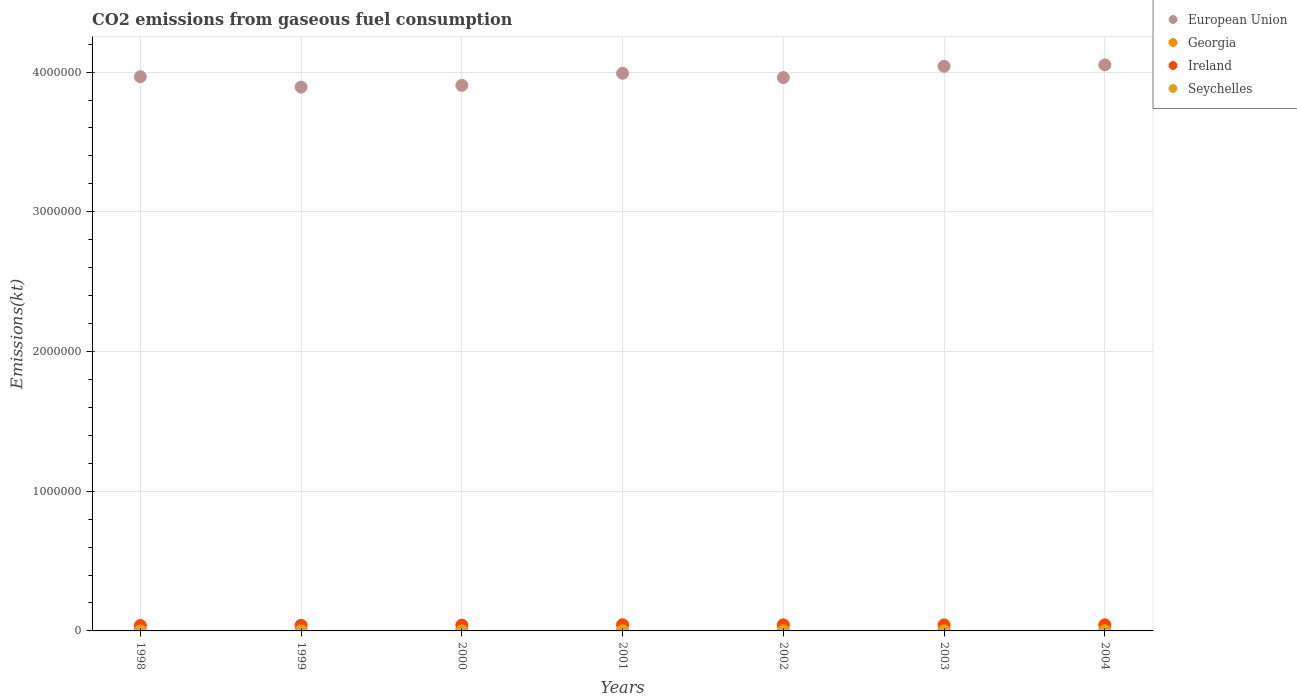How many different coloured dotlines are there?
Make the answer very short. 4. What is the amount of CO2 emitted in Georgia in 2004?
Your answer should be very brief. 4323.39. Across all years, what is the maximum amount of CO2 emitted in European Union?
Offer a terse response. 4.05e+06. Across all years, what is the minimum amount of CO2 emitted in Seychelles?
Keep it short and to the point. 432.71. In which year was the amount of CO2 emitted in Ireland maximum?
Provide a succinct answer. 2001. What is the total amount of CO2 emitted in European Union in the graph?
Offer a very short reply. 2.78e+07. What is the difference between the amount of CO2 emitted in Seychelles in 1998 and that in 2000?
Provide a succinct answer. -124.68. What is the difference between the amount of CO2 emitted in Ireland in 1999 and the amount of CO2 emitted in European Union in 2000?
Provide a short and direct response. -3.87e+06. What is the average amount of CO2 emitted in Georgia per year?
Provide a short and direct response. 4156.81. In the year 1998, what is the difference between the amount of CO2 emitted in Seychelles and amount of CO2 emitted in European Union?
Your answer should be compact. -3.97e+06. In how many years, is the amount of CO2 emitted in Seychelles greater than 1600000 kt?
Offer a very short reply. 0. What is the ratio of the amount of CO2 emitted in Seychelles in 2002 to that in 2004?
Your answer should be compact. 0.73. Is the amount of CO2 emitted in Seychelles in 1998 less than that in 2002?
Provide a short and direct response. Yes. Is the difference between the amount of CO2 emitted in Seychelles in 2000 and 2002 greater than the difference between the amount of CO2 emitted in European Union in 2000 and 2002?
Keep it short and to the point. Yes. What is the difference between the highest and the second highest amount of CO2 emitted in Georgia?
Offer a very short reply. 425.37. What is the difference between the highest and the lowest amount of CO2 emitted in European Union?
Keep it short and to the point. 1.59e+05. In how many years, is the amount of CO2 emitted in European Union greater than the average amount of CO2 emitted in European Union taken over all years?
Provide a succinct answer. 3. Is it the case that in every year, the sum of the amount of CO2 emitted in Seychelles and amount of CO2 emitted in Ireland  is greater than the sum of amount of CO2 emitted in European Union and amount of CO2 emitted in Georgia?
Give a very brief answer. No. Is it the case that in every year, the sum of the amount of CO2 emitted in Georgia and amount of CO2 emitted in Ireland  is greater than the amount of CO2 emitted in Seychelles?
Make the answer very short. Yes. Does the amount of CO2 emitted in European Union monotonically increase over the years?
Provide a short and direct response. No. Is the amount of CO2 emitted in European Union strictly greater than the amount of CO2 emitted in Seychelles over the years?
Make the answer very short. Yes. Is the amount of CO2 emitted in Seychelles strictly less than the amount of CO2 emitted in European Union over the years?
Offer a terse response. Yes. How many years are there in the graph?
Make the answer very short. 7. What is the difference between two consecutive major ticks on the Y-axis?
Ensure brevity in your answer.  1.00e+06. Are the values on the major ticks of Y-axis written in scientific E-notation?
Your response must be concise. No. Does the graph contain grids?
Ensure brevity in your answer.  Yes. How are the legend labels stacked?
Give a very brief answer. Vertical. What is the title of the graph?
Provide a succinct answer. CO2 emissions from gaseous fuel consumption. Does "Curacao" appear as one of the legend labels in the graph?
Offer a very short reply. No. What is the label or title of the X-axis?
Make the answer very short. Years. What is the label or title of the Y-axis?
Make the answer very short. Emissions(kt). What is the Emissions(kt) of European Union in 1998?
Provide a short and direct response. 3.97e+06. What is the Emissions(kt) of Georgia in 1998?
Ensure brevity in your answer.  4961.45. What is the Emissions(kt) of Ireland in 1998?
Give a very brief answer. 3.86e+04. What is the Emissions(kt) of Seychelles in 1998?
Provide a short and direct response. 432.71. What is the Emissions(kt) in European Union in 1999?
Your answer should be compact. 3.89e+06. What is the Emissions(kt) of Georgia in 1999?
Offer a very short reply. 4345.4. What is the Emissions(kt) in Ireland in 1999?
Give a very brief answer. 4.01e+04. What is the Emissions(kt) in Seychelles in 1999?
Give a very brief answer. 506.05. What is the Emissions(kt) in European Union in 2000?
Your answer should be compact. 3.91e+06. What is the Emissions(kt) in Georgia in 2000?
Provide a succinct answer. 4536.08. What is the Emissions(kt) in Ireland in 2000?
Offer a terse response. 4.12e+04. What is the Emissions(kt) of Seychelles in 2000?
Make the answer very short. 557.38. What is the Emissions(kt) in European Union in 2001?
Provide a succinct answer. 3.99e+06. What is the Emissions(kt) of Georgia in 2001?
Offer a terse response. 3769.68. What is the Emissions(kt) in Ireland in 2001?
Provide a succinct answer. 4.40e+04. What is the Emissions(kt) of Seychelles in 2001?
Offer a very short reply. 634.39. What is the Emissions(kt) of European Union in 2002?
Your answer should be compact. 3.96e+06. What is the Emissions(kt) in Georgia in 2002?
Offer a very short reply. 3388.31. What is the Emissions(kt) in Ireland in 2002?
Your answer should be compact. 4.36e+04. What is the Emissions(kt) in Seychelles in 2002?
Your answer should be very brief. 539.05. What is the Emissions(kt) of European Union in 2003?
Make the answer very short. 4.04e+06. What is the Emissions(kt) in Georgia in 2003?
Your response must be concise. 3773.34. What is the Emissions(kt) in Ireland in 2003?
Give a very brief answer. 4.32e+04. What is the Emissions(kt) of Seychelles in 2003?
Offer a very short reply. 550.05. What is the Emissions(kt) of European Union in 2004?
Your answer should be compact. 4.05e+06. What is the Emissions(kt) in Georgia in 2004?
Your response must be concise. 4323.39. What is the Emissions(kt) in Ireland in 2004?
Your answer should be compact. 4.38e+04. What is the Emissions(kt) of Seychelles in 2004?
Make the answer very short. 737.07. Across all years, what is the maximum Emissions(kt) in European Union?
Ensure brevity in your answer.  4.05e+06. Across all years, what is the maximum Emissions(kt) of Georgia?
Offer a very short reply. 4961.45. Across all years, what is the maximum Emissions(kt) of Ireland?
Give a very brief answer. 4.40e+04. Across all years, what is the maximum Emissions(kt) in Seychelles?
Offer a terse response. 737.07. Across all years, what is the minimum Emissions(kt) of European Union?
Give a very brief answer. 3.89e+06. Across all years, what is the minimum Emissions(kt) of Georgia?
Provide a short and direct response. 3388.31. Across all years, what is the minimum Emissions(kt) in Ireland?
Provide a succinct answer. 3.86e+04. Across all years, what is the minimum Emissions(kt) in Seychelles?
Your answer should be very brief. 432.71. What is the total Emissions(kt) in European Union in the graph?
Provide a short and direct response. 2.78e+07. What is the total Emissions(kt) in Georgia in the graph?
Your answer should be very brief. 2.91e+04. What is the total Emissions(kt) in Ireland in the graph?
Make the answer very short. 2.95e+05. What is the total Emissions(kt) in Seychelles in the graph?
Offer a terse response. 3956.69. What is the difference between the Emissions(kt) of European Union in 1998 and that in 1999?
Provide a succinct answer. 7.41e+04. What is the difference between the Emissions(kt) of Georgia in 1998 and that in 1999?
Ensure brevity in your answer.  616.06. What is the difference between the Emissions(kt) of Ireland in 1998 and that in 1999?
Your answer should be compact. -1573.14. What is the difference between the Emissions(kt) in Seychelles in 1998 and that in 1999?
Provide a short and direct response. -73.34. What is the difference between the Emissions(kt) of European Union in 1998 and that in 2000?
Give a very brief answer. 6.15e+04. What is the difference between the Emissions(kt) in Georgia in 1998 and that in 2000?
Offer a very short reply. 425.37. What is the difference between the Emissions(kt) in Ireland in 1998 and that in 2000?
Keep it short and to the point. -2669.58. What is the difference between the Emissions(kt) of Seychelles in 1998 and that in 2000?
Offer a terse response. -124.68. What is the difference between the Emissions(kt) of European Union in 1998 and that in 2001?
Keep it short and to the point. -2.48e+04. What is the difference between the Emissions(kt) of Georgia in 1998 and that in 2001?
Keep it short and to the point. 1191.78. What is the difference between the Emissions(kt) in Ireland in 1998 and that in 2001?
Keep it short and to the point. -5460.16. What is the difference between the Emissions(kt) in Seychelles in 1998 and that in 2001?
Your response must be concise. -201.69. What is the difference between the Emissions(kt) of European Union in 1998 and that in 2002?
Ensure brevity in your answer.  5999.21. What is the difference between the Emissions(kt) in Georgia in 1998 and that in 2002?
Provide a succinct answer. 1573.14. What is the difference between the Emissions(kt) in Ireland in 1998 and that in 2002?
Make the answer very short. -5053.13. What is the difference between the Emissions(kt) of Seychelles in 1998 and that in 2002?
Keep it short and to the point. -106.34. What is the difference between the Emissions(kt) in European Union in 1998 and that in 2003?
Make the answer very short. -7.47e+04. What is the difference between the Emissions(kt) of Georgia in 1998 and that in 2003?
Make the answer very short. 1188.11. What is the difference between the Emissions(kt) of Ireland in 1998 and that in 2003?
Provide a succinct answer. -4635.09. What is the difference between the Emissions(kt) in Seychelles in 1998 and that in 2003?
Offer a very short reply. -117.34. What is the difference between the Emissions(kt) in European Union in 1998 and that in 2004?
Keep it short and to the point. -8.50e+04. What is the difference between the Emissions(kt) of Georgia in 1998 and that in 2004?
Give a very brief answer. 638.06. What is the difference between the Emissions(kt) in Ireland in 1998 and that in 2004?
Offer a very short reply. -5254.81. What is the difference between the Emissions(kt) in Seychelles in 1998 and that in 2004?
Provide a succinct answer. -304.36. What is the difference between the Emissions(kt) in European Union in 1999 and that in 2000?
Give a very brief answer. -1.26e+04. What is the difference between the Emissions(kt) in Georgia in 1999 and that in 2000?
Provide a succinct answer. -190.68. What is the difference between the Emissions(kt) of Ireland in 1999 and that in 2000?
Offer a terse response. -1096.43. What is the difference between the Emissions(kt) of Seychelles in 1999 and that in 2000?
Your response must be concise. -51.34. What is the difference between the Emissions(kt) in European Union in 1999 and that in 2001?
Keep it short and to the point. -9.89e+04. What is the difference between the Emissions(kt) in Georgia in 1999 and that in 2001?
Your answer should be compact. 575.72. What is the difference between the Emissions(kt) of Ireland in 1999 and that in 2001?
Ensure brevity in your answer.  -3887.02. What is the difference between the Emissions(kt) of Seychelles in 1999 and that in 2001?
Provide a short and direct response. -128.34. What is the difference between the Emissions(kt) in European Union in 1999 and that in 2002?
Ensure brevity in your answer.  -6.81e+04. What is the difference between the Emissions(kt) of Georgia in 1999 and that in 2002?
Ensure brevity in your answer.  957.09. What is the difference between the Emissions(kt) in Ireland in 1999 and that in 2002?
Offer a very short reply. -3479.98. What is the difference between the Emissions(kt) in Seychelles in 1999 and that in 2002?
Keep it short and to the point. -33. What is the difference between the Emissions(kt) of European Union in 1999 and that in 2003?
Offer a very short reply. -1.49e+05. What is the difference between the Emissions(kt) in Georgia in 1999 and that in 2003?
Offer a terse response. 572.05. What is the difference between the Emissions(kt) in Ireland in 1999 and that in 2003?
Keep it short and to the point. -3061.95. What is the difference between the Emissions(kt) of Seychelles in 1999 and that in 2003?
Provide a succinct answer. -44. What is the difference between the Emissions(kt) of European Union in 1999 and that in 2004?
Provide a succinct answer. -1.59e+05. What is the difference between the Emissions(kt) in Georgia in 1999 and that in 2004?
Provide a short and direct response. 22. What is the difference between the Emissions(kt) of Ireland in 1999 and that in 2004?
Offer a very short reply. -3681.67. What is the difference between the Emissions(kt) of Seychelles in 1999 and that in 2004?
Your answer should be compact. -231.02. What is the difference between the Emissions(kt) of European Union in 2000 and that in 2001?
Ensure brevity in your answer.  -8.63e+04. What is the difference between the Emissions(kt) in Georgia in 2000 and that in 2001?
Give a very brief answer. 766.4. What is the difference between the Emissions(kt) in Ireland in 2000 and that in 2001?
Keep it short and to the point. -2790.59. What is the difference between the Emissions(kt) in Seychelles in 2000 and that in 2001?
Give a very brief answer. -77.01. What is the difference between the Emissions(kt) in European Union in 2000 and that in 2002?
Offer a terse response. -5.55e+04. What is the difference between the Emissions(kt) in Georgia in 2000 and that in 2002?
Provide a succinct answer. 1147.77. What is the difference between the Emissions(kt) of Ireland in 2000 and that in 2002?
Provide a short and direct response. -2383.55. What is the difference between the Emissions(kt) of Seychelles in 2000 and that in 2002?
Your answer should be very brief. 18.34. What is the difference between the Emissions(kt) in European Union in 2000 and that in 2003?
Offer a terse response. -1.36e+05. What is the difference between the Emissions(kt) of Georgia in 2000 and that in 2003?
Keep it short and to the point. 762.74. What is the difference between the Emissions(kt) of Ireland in 2000 and that in 2003?
Offer a very short reply. -1965.51. What is the difference between the Emissions(kt) of Seychelles in 2000 and that in 2003?
Provide a succinct answer. 7.33. What is the difference between the Emissions(kt) in European Union in 2000 and that in 2004?
Your response must be concise. -1.46e+05. What is the difference between the Emissions(kt) in Georgia in 2000 and that in 2004?
Offer a terse response. 212.69. What is the difference between the Emissions(kt) of Ireland in 2000 and that in 2004?
Your answer should be compact. -2585.24. What is the difference between the Emissions(kt) in Seychelles in 2000 and that in 2004?
Provide a short and direct response. -179.68. What is the difference between the Emissions(kt) in European Union in 2001 and that in 2002?
Provide a succinct answer. 3.08e+04. What is the difference between the Emissions(kt) in Georgia in 2001 and that in 2002?
Your answer should be compact. 381.37. What is the difference between the Emissions(kt) of Ireland in 2001 and that in 2002?
Offer a very short reply. 407.04. What is the difference between the Emissions(kt) in Seychelles in 2001 and that in 2002?
Provide a short and direct response. 95.34. What is the difference between the Emissions(kt) of European Union in 2001 and that in 2003?
Keep it short and to the point. -4.99e+04. What is the difference between the Emissions(kt) in Georgia in 2001 and that in 2003?
Ensure brevity in your answer.  -3.67. What is the difference between the Emissions(kt) of Ireland in 2001 and that in 2003?
Give a very brief answer. 825.08. What is the difference between the Emissions(kt) in Seychelles in 2001 and that in 2003?
Provide a short and direct response. 84.34. What is the difference between the Emissions(kt) of European Union in 2001 and that in 2004?
Offer a terse response. -6.02e+04. What is the difference between the Emissions(kt) of Georgia in 2001 and that in 2004?
Offer a terse response. -553.72. What is the difference between the Emissions(kt) in Ireland in 2001 and that in 2004?
Give a very brief answer. 205.35. What is the difference between the Emissions(kt) of Seychelles in 2001 and that in 2004?
Your response must be concise. -102.68. What is the difference between the Emissions(kt) in European Union in 2002 and that in 2003?
Make the answer very short. -8.07e+04. What is the difference between the Emissions(kt) of Georgia in 2002 and that in 2003?
Your answer should be compact. -385.04. What is the difference between the Emissions(kt) in Ireland in 2002 and that in 2003?
Your answer should be compact. 418.04. What is the difference between the Emissions(kt) in Seychelles in 2002 and that in 2003?
Your response must be concise. -11. What is the difference between the Emissions(kt) in European Union in 2002 and that in 2004?
Your answer should be compact. -9.10e+04. What is the difference between the Emissions(kt) of Georgia in 2002 and that in 2004?
Your response must be concise. -935.09. What is the difference between the Emissions(kt) in Ireland in 2002 and that in 2004?
Your answer should be compact. -201.69. What is the difference between the Emissions(kt) in Seychelles in 2002 and that in 2004?
Ensure brevity in your answer.  -198.02. What is the difference between the Emissions(kt) of European Union in 2003 and that in 2004?
Offer a very short reply. -1.03e+04. What is the difference between the Emissions(kt) in Georgia in 2003 and that in 2004?
Make the answer very short. -550.05. What is the difference between the Emissions(kt) of Ireland in 2003 and that in 2004?
Make the answer very short. -619.72. What is the difference between the Emissions(kt) of Seychelles in 2003 and that in 2004?
Keep it short and to the point. -187.02. What is the difference between the Emissions(kt) in European Union in 1998 and the Emissions(kt) in Georgia in 1999?
Your response must be concise. 3.96e+06. What is the difference between the Emissions(kt) of European Union in 1998 and the Emissions(kt) of Ireland in 1999?
Offer a terse response. 3.93e+06. What is the difference between the Emissions(kt) of European Union in 1998 and the Emissions(kt) of Seychelles in 1999?
Keep it short and to the point. 3.97e+06. What is the difference between the Emissions(kt) in Georgia in 1998 and the Emissions(kt) in Ireland in 1999?
Offer a very short reply. -3.52e+04. What is the difference between the Emissions(kt) of Georgia in 1998 and the Emissions(kt) of Seychelles in 1999?
Make the answer very short. 4455.4. What is the difference between the Emissions(kt) in Ireland in 1998 and the Emissions(kt) in Seychelles in 1999?
Your response must be concise. 3.81e+04. What is the difference between the Emissions(kt) in European Union in 1998 and the Emissions(kt) in Georgia in 2000?
Make the answer very short. 3.96e+06. What is the difference between the Emissions(kt) of European Union in 1998 and the Emissions(kt) of Ireland in 2000?
Your answer should be compact. 3.93e+06. What is the difference between the Emissions(kt) in European Union in 1998 and the Emissions(kt) in Seychelles in 2000?
Keep it short and to the point. 3.97e+06. What is the difference between the Emissions(kt) in Georgia in 1998 and the Emissions(kt) in Ireland in 2000?
Provide a succinct answer. -3.63e+04. What is the difference between the Emissions(kt) in Georgia in 1998 and the Emissions(kt) in Seychelles in 2000?
Provide a short and direct response. 4404.07. What is the difference between the Emissions(kt) of Ireland in 1998 and the Emissions(kt) of Seychelles in 2000?
Your response must be concise. 3.80e+04. What is the difference between the Emissions(kt) of European Union in 1998 and the Emissions(kt) of Georgia in 2001?
Make the answer very short. 3.96e+06. What is the difference between the Emissions(kt) in European Union in 1998 and the Emissions(kt) in Ireland in 2001?
Your answer should be very brief. 3.92e+06. What is the difference between the Emissions(kt) of European Union in 1998 and the Emissions(kt) of Seychelles in 2001?
Make the answer very short. 3.97e+06. What is the difference between the Emissions(kt) of Georgia in 1998 and the Emissions(kt) of Ireland in 2001?
Your answer should be very brief. -3.91e+04. What is the difference between the Emissions(kt) in Georgia in 1998 and the Emissions(kt) in Seychelles in 2001?
Keep it short and to the point. 4327.06. What is the difference between the Emissions(kt) in Ireland in 1998 and the Emissions(kt) in Seychelles in 2001?
Give a very brief answer. 3.79e+04. What is the difference between the Emissions(kt) of European Union in 1998 and the Emissions(kt) of Georgia in 2002?
Make the answer very short. 3.96e+06. What is the difference between the Emissions(kt) of European Union in 1998 and the Emissions(kt) of Ireland in 2002?
Give a very brief answer. 3.92e+06. What is the difference between the Emissions(kt) in European Union in 1998 and the Emissions(kt) in Seychelles in 2002?
Give a very brief answer. 3.97e+06. What is the difference between the Emissions(kt) in Georgia in 1998 and the Emissions(kt) in Ireland in 2002?
Offer a terse response. -3.87e+04. What is the difference between the Emissions(kt) in Georgia in 1998 and the Emissions(kt) in Seychelles in 2002?
Offer a terse response. 4422.4. What is the difference between the Emissions(kt) in Ireland in 1998 and the Emissions(kt) in Seychelles in 2002?
Your response must be concise. 3.80e+04. What is the difference between the Emissions(kt) of European Union in 1998 and the Emissions(kt) of Georgia in 2003?
Ensure brevity in your answer.  3.96e+06. What is the difference between the Emissions(kt) in European Union in 1998 and the Emissions(kt) in Ireland in 2003?
Give a very brief answer. 3.92e+06. What is the difference between the Emissions(kt) of European Union in 1998 and the Emissions(kt) of Seychelles in 2003?
Provide a succinct answer. 3.97e+06. What is the difference between the Emissions(kt) of Georgia in 1998 and the Emissions(kt) of Ireland in 2003?
Offer a terse response. -3.82e+04. What is the difference between the Emissions(kt) in Georgia in 1998 and the Emissions(kt) in Seychelles in 2003?
Provide a succinct answer. 4411.4. What is the difference between the Emissions(kt) in Ireland in 1998 and the Emissions(kt) in Seychelles in 2003?
Provide a succinct answer. 3.80e+04. What is the difference between the Emissions(kt) of European Union in 1998 and the Emissions(kt) of Georgia in 2004?
Offer a terse response. 3.96e+06. What is the difference between the Emissions(kt) of European Union in 1998 and the Emissions(kt) of Ireland in 2004?
Keep it short and to the point. 3.92e+06. What is the difference between the Emissions(kt) in European Union in 1998 and the Emissions(kt) in Seychelles in 2004?
Offer a terse response. 3.97e+06. What is the difference between the Emissions(kt) of Georgia in 1998 and the Emissions(kt) of Ireland in 2004?
Provide a succinct answer. -3.89e+04. What is the difference between the Emissions(kt) of Georgia in 1998 and the Emissions(kt) of Seychelles in 2004?
Your answer should be very brief. 4224.38. What is the difference between the Emissions(kt) in Ireland in 1998 and the Emissions(kt) in Seychelles in 2004?
Ensure brevity in your answer.  3.78e+04. What is the difference between the Emissions(kt) of European Union in 1999 and the Emissions(kt) of Georgia in 2000?
Provide a succinct answer. 3.89e+06. What is the difference between the Emissions(kt) of European Union in 1999 and the Emissions(kt) of Ireland in 2000?
Keep it short and to the point. 3.85e+06. What is the difference between the Emissions(kt) in European Union in 1999 and the Emissions(kt) in Seychelles in 2000?
Provide a succinct answer. 3.89e+06. What is the difference between the Emissions(kt) of Georgia in 1999 and the Emissions(kt) of Ireland in 2000?
Offer a very short reply. -3.69e+04. What is the difference between the Emissions(kt) in Georgia in 1999 and the Emissions(kt) in Seychelles in 2000?
Offer a very short reply. 3788.01. What is the difference between the Emissions(kt) in Ireland in 1999 and the Emissions(kt) in Seychelles in 2000?
Keep it short and to the point. 3.96e+04. What is the difference between the Emissions(kt) of European Union in 1999 and the Emissions(kt) of Georgia in 2001?
Offer a terse response. 3.89e+06. What is the difference between the Emissions(kt) of European Union in 1999 and the Emissions(kt) of Ireland in 2001?
Your answer should be very brief. 3.85e+06. What is the difference between the Emissions(kt) of European Union in 1999 and the Emissions(kt) of Seychelles in 2001?
Provide a short and direct response. 3.89e+06. What is the difference between the Emissions(kt) of Georgia in 1999 and the Emissions(kt) of Ireland in 2001?
Your answer should be compact. -3.97e+04. What is the difference between the Emissions(kt) of Georgia in 1999 and the Emissions(kt) of Seychelles in 2001?
Make the answer very short. 3711. What is the difference between the Emissions(kt) of Ireland in 1999 and the Emissions(kt) of Seychelles in 2001?
Make the answer very short. 3.95e+04. What is the difference between the Emissions(kt) of European Union in 1999 and the Emissions(kt) of Georgia in 2002?
Your response must be concise. 3.89e+06. What is the difference between the Emissions(kt) of European Union in 1999 and the Emissions(kt) of Ireland in 2002?
Give a very brief answer. 3.85e+06. What is the difference between the Emissions(kt) of European Union in 1999 and the Emissions(kt) of Seychelles in 2002?
Provide a succinct answer. 3.89e+06. What is the difference between the Emissions(kt) of Georgia in 1999 and the Emissions(kt) of Ireland in 2002?
Give a very brief answer. -3.93e+04. What is the difference between the Emissions(kt) of Georgia in 1999 and the Emissions(kt) of Seychelles in 2002?
Give a very brief answer. 3806.35. What is the difference between the Emissions(kt) in Ireland in 1999 and the Emissions(kt) in Seychelles in 2002?
Offer a very short reply. 3.96e+04. What is the difference between the Emissions(kt) of European Union in 1999 and the Emissions(kt) of Georgia in 2003?
Your answer should be compact. 3.89e+06. What is the difference between the Emissions(kt) in European Union in 1999 and the Emissions(kt) in Ireland in 2003?
Ensure brevity in your answer.  3.85e+06. What is the difference between the Emissions(kt) in European Union in 1999 and the Emissions(kt) in Seychelles in 2003?
Make the answer very short. 3.89e+06. What is the difference between the Emissions(kt) of Georgia in 1999 and the Emissions(kt) of Ireland in 2003?
Keep it short and to the point. -3.89e+04. What is the difference between the Emissions(kt) of Georgia in 1999 and the Emissions(kt) of Seychelles in 2003?
Keep it short and to the point. 3795.34. What is the difference between the Emissions(kt) of Ireland in 1999 and the Emissions(kt) of Seychelles in 2003?
Offer a very short reply. 3.96e+04. What is the difference between the Emissions(kt) in European Union in 1999 and the Emissions(kt) in Georgia in 2004?
Give a very brief answer. 3.89e+06. What is the difference between the Emissions(kt) in European Union in 1999 and the Emissions(kt) in Ireland in 2004?
Offer a terse response. 3.85e+06. What is the difference between the Emissions(kt) in European Union in 1999 and the Emissions(kt) in Seychelles in 2004?
Your response must be concise. 3.89e+06. What is the difference between the Emissions(kt) in Georgia in 1999 and the Emissions(kt) in Ireland in 2004?
Provide a short and direct response. -3.95e+04. What is the difference between the Emissions(kt) in Georgia in 1999 and the Emissions(kt) in Seychelles in 2004?
Your response must be concise. 3608.33. What is the difference between the Emissions(kt) of Ireland in 1999 and the Emissions(kt) of Seychelles in 2004?
Your response must be concise. 3.94e+04. What is the difference between the Emissions(kt) in European Union in 2000 and the Emissions(kt) in Georgia in 2001?
Provide a succinct answer. 3.90e+06. What is the difference between the Emissions(kt) in European Union in 2000 and the Emissions(kt) in Ireland in 2001?
Ensure brevity in your answer.  3.86e+06. What is the difference between the Emissions(kt) of European Union in 2000 and the Emissions(kt) of Seychelles in 2001?
Your response must be concise. 3.90e+06. What is the difference between the Emissions(kt) in Georgia in 2000 and the Emissions(kt) in Ireland in 2001?
Give a very brief answer. -3.95e+04. What is the difference between the Emissions(kt) of Georgia in 2000 and the Emissions(kt) of Seychelles in 2001?
Your response must be concise. 3901.69. What is the difference between the Emissions(kt) in Ireland in 2000 and the Emissions(kt) in Seychelles in 2001?
Your response must be concise. 4.06e+04. What is the difference between the Emissions(kt) in European Union in 2000 and the Emissions(kt) in Georgia in 2002?
Provide a succinct answer. 3.90e+06. What is the difference between the Emissions(kt) of European Union in 2000 and the Emissions(kt) of Ireland in 2002?
Keep it short and to the point. 3.86e+06. What is the difference between the Emissions(kt) of European Union in 2000 and the Emissions(kt) of Seychelles in 2002?
Offer a terse response. 3.90e+06. What is the difference between the Emissions(kt) in Georgia in 2000 and the Emissions(kt) in Ireland in 2002?
Make the answer very short. -3.91e+04. What is the difference between the Emissions(kt) of Georgia in 2000 and the Emissions(kt) of Seychelles in 2002?
Your answer should be compact. 3997.03. What is the difference between the Emissions(kt) in Ireland in 2000 and the Emissions(kt) in Seychelles in 2002?
Ensure brevity in your answer.  4.07e+04. What is the difference between the Emissions(kt) of European Union in 2000 and the Emissions(kt) of Georgia in 2003?
Offer a very short reply. 3.90e+06. What is the difference between the Emissions(kt) of European Union in 2000 and the Emissions(kt) of Ireland in 2003?
Provide a succinct answer. 3.86e+06. What is the difference between the Emissions(kt) of European Union in 2000 and the Emissions(kt) of Seychelles in 2003?
Your answer should be very brief. 3.90e+06. What is the difference between the Emissions(kt) of Georgia in 2000 and the Emissions(kt) of Ireland in 2003?
Provide a succinct answer. -3.87e+04. What is the difference between the Emissions(kt) in Georgia in 2000 and the Emissions(kt) in Seychelles in 2003?
Provide a short and direct response. 3986.03. What is the difference between the Emissions(kt) of Ireland in 2000 and the Emissions(kt) of Seychelles in 2003?
Give a very brief answer. 4.07e+04. What is the difference between the Emissions(kt) in European Union in 2000 and the Emissions(kt) in Georgia in 2004?
Your answer should be very brief. 3.90e+06. What is the difference between the Emissions(kt) of European Union in 2000 and the Emissions(kt) of Ireland in 2004?
Make the answer very short. 3.86e+06. What is the difference between the Emissions(kt) of European Union in 2000 and the Emissions(kt) of Seychelles in 2004?
Ensure brevity in your answer.  3.90e+06. What is the difference between the Emissions(kt) of Georgia in 2000 and the Emissions(kt) of Ireland in 2004?
Your answer should be compact. -3.93e+04. What is the difference between the Emissions(kt) of Georgia in 2000 and the Emissions(kt) of Seychelles in 2004?
Your answer should be very brief. 3799.01. What is the difference between the Emissions(kt) of Ireland in 2000 and the Emissions(kt) of Seychelles in 2004?
Offer a very short reply. 4.05e+04. What is the difference between the Emissions(kt) of European Union in 2001 and the Emissions(kt) of Georgia in 2002?
Keep it short and to the point. 3.99e+06. What is the difference between the Emissions(kt) of European Union in 2001 and the Emissions(kt) of Ireland in 2002?
Your response must be concise. 3.95e+06. What is the difference between the Emissions(kt) in European Union in 2001 and the Emissions(kt) in Seychelles in 2002?
Provide a short and direct response. 3.99e+06. What is the difference between the Emissions(kt) of Georgia in 2001 and the Emissions(kt) of Ireland in 2002?
Make the answer very short. -3.98e+04. What is the difference between the Emissions(kt) of Georgia in 2001 and the Emissions(kt) of Seychelles in 2002?
Make the answer very short. 3230.63. What is the difference between the Emissions(kt) in Ireland in 2001 and the Emissions(kt) in Seychelles in 2002?
Provide a succinct answer. 4.35e+04. What is the difference between the Emissions(kt) of European Union in 2001 and the Emissions(kt) of Georgia in 2003?
Your answer should be very brief. 3.99e+06. What is the difference between the Emissions(kt) in European Union in 2001 and the Emissions(kt) in Ireland in 2003?
Offer a terse response. 3.95e+06. What is the difference between the Emissions(kt) in European Union in 2001 and the Emissions(kt) in Seychelles in 2003?
Keep it short and to the point. 3.99e+06. What is the difference between the Emissions(kt) in Georgia in 2001 and the Emissions(kt) in Ireland in 2003?
Keep it short and to the point. -3.94e+04. What is the difference between the Emissions(kt) in Georgia in 2001 and the Emissions(kt) in Seychelles in 2003?
Your answer should be compact. 3219.63. What is the difference between the Emissions(kt) in Ireland in 2001 and the Emissions(kt) in Seychelles in 2003?
Give a very brief answer. 4.35e+04. What is the difference between the Emissions(kt) in European Union in 2001 and the Emissions(kt) in Georgia in 2004?
Your answer should be very brief. 3.99e+06. What is the difference between the Emissions(kt) in European Union in 2001 and the Emissions(kt) in Ireland in 2004?
Give a very brief answer. 3.95e+06. What is the difference between the Emissions(kt) in European Union in 2001 and the Emissions(kt) in Seychelles in 2004?
Ensure brevity in your answer.  3.99e+06. What is the difference between the Emissions(kt) of Georgia in 2001 and the Emissions(kt) of Ireland in 2004?
Provide a succinct answer. -4.01e+04. What is the difference between the Emissions(kt) in Georgia in 2001 and the Emissions(kt) in Seychelles in 2004?
Offer a very short reply. 3032.61. What is the difference between the Emissions(kt) of Ireland in 2001 and the Emissions(kt) of Seychelles in 2004?
Your response must be concise. 4.33e+04. What is the difference between the Emissions(kt) of European Union in 2002 and the Emissions(kt) of Georgia in 2003?
Your answer should be compact. 3.96e+06. What is the difference between the Emissions(kt) of European Union in 2002 and the Emissions(kt) of Ireland in 2003?
Provide a short and direct response. 3.92e+06. What is the difference between the Emissions(kt) in European Union in 2002 and the Emissions(kt) in Seychelles in 2003?
Ensure brevity in your answer.  3.96e+06. What is the difference between the Emissions(kt) in Georgia in 2002 and the Emissions(kt) in Ireland in 2003?
Your answer should be very brief. -3.98e+04. What is the difference between the Emissions(kt) of Georgia in 2002 and the Emissions(kt) of Seychelles in 2003?
Offer a terse response. 2838.26. What is the difference between the Emissions(kt) in Ireland in 2002 and the Emissions(kt) in Seychelles in 2003?
Ensure brevity in your answer.  4.31e+04. What is the difference between the Emissions(kt) of European Union in 2002 and the Emissions(kt) of Georgia in 2004?
Your response must be concise. 3.96e+06. What is the difference between the Emissions(kt) of European Union in 2002 and the Emissions(kt) of Ireland in 2004?
Provide a succinct answer. 3.92e+06. What is the difference between the Emissions(kt) in European Union in 2002 and the Emissions(kt) in Seychelles in 2004?
Give a very brief answer. 3.96e+06. What is the difference between the Emissions(kt) of Georgia in 2002 and the Emissions(kt) of Ireland in 2004?
Offer a terse response. -4.04e+04. What is the difference between the Emissions(kt) of Georgia in 2002 and the Emissions(kt) of Seychelles in 2004?
Make the answer very short. 2651.24. What is the difference between the Emissions(kt) of Ireland in 2002 and the Emissions(kt) of Seychelles in 2004?
Offer a terse response. 4.29e+04. What is the difference between the Emissions(kt) in European Union in 2003 and the Emissions(kt) in Georgia in 2004?
Offer a very short reply. 4.04e+06. What is the difference between the Emissions(kt) in European Union in 2003 and the Emissions(kt) in Ireland in 2004?
Offer a very short reply. 4.00e+06. What is the difference between the Emissions(kt) of European Union in 2003 and the Emissions(kt) of Seychelles in 2004?
Your answer should be very brief. 4.04e+06. What is the difference between the Emissions(kt) in Georgia in 2003 and the Emissions(kt) in Ireland in 2004?
Provide a succinct answer. -4.00e+04. What is the difference between the Emissions(kt) in Georgia in 2003 and the Emissions(kt) in Seychelles in 2004?
Offer a very short reply. 3036.28. What is the difference between the Emissions(kt) in Ireland in 2003 and the Emissions(kt) in Seychelles in 2004?
Ensure brevity in your answer.  4.25e+04. What is the average Emissions(kt) of European Union per year?
Provide a succinct answer. 3.97e+06. What is the average Emissions(kt) in Georgia per year?
Provide a succinct answer. 4156.81. What is the average Emissions(kt) of Ireland per year?
Your response must be concise. 4.21e+04. What is the average Emissions(kt) of Seychelles per year?
Your response must be concise. 565.24. In the year 1998, what is the difference between the Emissions(kt) of European Union and Emissions(kt) of Georgia?
Give a very brief answer. 3.96e+06. In the year 1998, what is the difference between the Emissions(kt) in European Union and Emissions(kt) in Ireland?
Keep it short and to the point. 3.93e+06. In the year 1998, what is the difference between the Emissions(kt) of European Union and Emissions(kt) of Seychelles?
Your answer should be very brief. 3.97e+06. In the year 1998, what is the difference between the Emissions(kt) of Georgia and Emissions(kt) of Ireland?
Provide a succinct answer. -3.36e+04. In the year 1998, what is the difference between the Emissions(kt) of Georgia and Emissions(kt) of Seychelles?
Your answer should be very brief. 4528.74. In the year 1998, what is the difference between the Emissions(kt) in Ireland and Emissions(kt) in Seychelles?
Your answer should be compact. 3.81e+04. In the year 1999, what is the difference between the Emissions(kt) in European Union and Emissions(kt) in Georgia?
Give a very brief answer. 3.89e+06. In the year 1999, what is the difference between the Emissions(kt) in European Union and Emissions(kt) in Ireland?
Provide a short and direct response. 3.85e+06. In the year 1999, what is the difference between the Emissions(kt) of European Union and Emissions(kt) of Seychelles?
Make the answer very short. 3.89e+06. In the year 1999, what is the difference between the Emissions(kt) of Georgia and Emissions(kt) of Ireland?
Your response must be concise. -3.58e+04. In the year 1999, what is the difference between the Emissions(kt) in Georgia and Emissions(kt) in Seychelles?
Offer a very short reply. 3839.35. In the year 1999, what is the difference between the Emissions(kt) in Ireland and Emissions(kt) in Seychelles?
Give a very brief answer. 3.96e+04. In the year 2000, what is the difference between the Emissions(kt) of European Union and Emissions(kt) of Georgia?
Your answer should be very brief. 3.90e+06. In the year 2000, what is the difference between the Emissions(kt) in European Union and Emissions(kt) in Ireland?
Ensure brevity in your answer.  3.86e+06. In the year 2000, what is the difference between the Emissions(kt) of European Union and Emissions(kt) of Seychelles?
Provide a succinct answer. 3.90e+06. In the year 2000, what is the difference between the Emissions(kt) of Georgia and Emissions(kt) of Ireland?
Ensure brevity in your answer.  -3.67e+04. In the year 2000, what is the difference between the Emissions(kt) in Georgia and Emissions(kt) in Seychelles?
Your response must be concise. 3978.7. In the year 2000, what is the difference between the Emissions(kt) in Ireland and Emissions(kt) in Seychelles?
Keep it short and to the point. 4.07e+04. In the year 2001, what is the difference between the Emissions(kt) in European Union and Emissions(kt) in Georgia?
Provide a short and direct response. 3.99e+06. In the year 2001, what is the difference between the Emissions(kt) of European Union and Emissions(kt) of Ireland?
Your answer should be very brief. 3.95e+06. In the year 2001, what is the difference between the Emissions(kt) of European Union and Emissions(kt) of Seychelles?
Keep it short and to the point. 3.99e+06. In the year 2001, what is the difference between the Emissions(kt) in Georgia and Emissions(kt) in Ireland?
Keep it short and to the point. -4.03e+04. In the year 2001, what is the difference between the Emissions(kt) in Georgia and Emissions(kt) in Seychelles?
Your answer should be compact. 3135.28. In the year 2001, what is the difference between the Emissions(kt) in Ireland and Emissions(kt) in Seychelles?
Give a very brief answer. 4.34e+04. In the year 2002, what is the difference between the Emissions(kt) in European Union and Emissions(kt) in Georgia?
Make the answer very short. 3.96e+06. In the year 2002, what is the difference between the Emissions(kt) of European Union and Emissions(kt) of Ireland?
Your answer should be very brief. 3.92e+06. In the year 2002, what is the difference between the Emissions(kt) of European Union and Emissions(kt) of Seychelles?
Offer a terse response. 3.96e+06. In the year 2002, what is the difference between the Emissions(kt) of Georgia and Emissions(kt) of Ireland?
Ensure brevity in your answer.  -4.02e+04. In the year 2002, what is the difference between the Emissions(kt) in Georgia and Emissions(kt) in Seychelles?
Your response must be concise. 2849.26. In the year 2002, what is the difference between the Emissions(kt) of Ireland and Emissions(kt) of Seychelles?
Give a very brief answer. 4.31e+04. In the year 2003, what is the difference between the Emissions(kt) of European Union and Emissions(kt) of Georgia?
Keep it short and to the point. 4.04e+06. In the year 2003, what is the difference between the Emissions(kt) in European Union and Emissions(kt) in Ireland?
Make the answer very short. 4.00e+06. In the year 2003, what is the difference between the Emissions(kt) in European Union and Emissions(kt) in Seychelles?
Give a very brief answer. 4.04e+06. In the year 2003, what is the difference between the Emissions(kt) of Georgia and Emissions(kt) of Ireland?
Give a very brief answer. -3.94e+04. In the year 2003, what is the difference between the Emissions(kt) in Georgia and Emissions(kt) in Seychelles?
Make the answer very short. 3223.29. In the year 2003, what is the difference between the Emissions(kt) in Ireland and Emissions(kt) in Seychelles?
Offer a terse response. 4.27e+04. In the year 2004, what is the difference between the Emissions(kt) in European Union and Emissions(kt) in Georgia?
Provide a succinct answer. 4.05e+06. In the year 2004, what is the difference between the Emissions(kt) of European Union and Emissions(kt) of Ireland?
Give a very brief answer. 4.01e+06. In the year 2004, what is the difference between the Emissions(kt) in European Union and Emissions(kt) in Seychelles?
Offer a very short reply. 4.05e+06. In the year 2004, what is the difference between the Emissions(kt) in Georgia and Emissions(kt) in Ireland?
Provide a short and direct response. -3.95e+04. In the year 2004, what is the difference between the Emissions(kt) of Georgia and Emissions(kt) of Seychelles?
Provide a short and direct response. 3586.33. In the year 2004, what is the difference between the Emissions(kt) of Ireland and Emissions(kt) of Seychelles?
Your answer should be very brief. 4.31e+04. What is the ratio of the Emissions(kt) of Georgia in 1998 to that in 1999?
Offer a very short reply. 1.14. What is the ratio of the Emissions(kt) in Ireland in 1998 to that in 1999?
Make the answer very short. 0.96. What is the ratio of the Emissions(kt) of Seychelles in 1998 to that in 1999?
Your answer should be very brief. 0.86. What is the ratio of the Emissions(kt) in European Union in 1998 to that in 2000?
Keep it short and to the point. 1.02. What is the ratio of the Emissions(kt) of Georgia in 1998 to that in 2000?
Ensure brevity in your answer.  1.09. What is the ratio of the Emissions(kt) in Ireland in 1998 to that in 2000?
Keep it short and to the point. 0.94. What is the ratio of the Emissions(kt) of Seychelles in 1998 to that in 2000?
Give a very brief answer. 0.78. What is the ratio of the Emissions(kt) in European Union in 1998 to that in 2001?
Keep it short and to the point. 0.99. What is the ratio of the Emissions(kt) in Georgia in 1998 to that in 2001?
Give a very brief answer. 1.32. What is the ratio of the Emissions(kt) in Ireland in 1998 to that in 2001?
Make the answer very short. 0.88. What is the ratio of the Emissions(kt) in Seychelles in 1998 to that in 2001?
Offer a terse response. 0.68. What is the ratio of the Emissions(kt) of European Union in 1998 to that in 2002?
Make the answer very short. 1. What is the ratio of the Emissions(kt) of Georgia in 1998 to that in 2002?
Offer a very short reply. 1.46. What is the ratio of the Emissions(kt) of Ireland in 1998 to that in 2002?
Provide a short and direct response. 0.88. What is the ratio of the Emissions(kt) in Seychelles in 1998 to that in 2002?
Offer a very short reply. 0.8. What is the ratio of the Emissions(kt) of European Union in 1998 to that in 2003?
Provide a short and direct response. 0.98. What is the ratio of the Emissions(kt) of Georgia in 1998 to that in 2003?
Give a very brief answer. 1.31. What is the ratio of the Emissions(kt) in Ireland in 1998 to that in 2003?
Your response must be concise. 0.89. What is the ratio of the Emissions(kt) of Seychelles in 1998 to that in 2003?
Your answer should be compact. 0.79. What is the ratio of the Emissions(kt) of Georgia in 1998 to that in 2004?
Provide a short and direct response. 1.15. What is the ratio of the Emissions(kt) of Ireland in 1998 to that in 2004?
Your answer should be very brief. 0.88. What is the ratio of the Emissions(kt) in Seychelles in 1998 to that in 2004?
Provide a succinct answer. 0.59. What is the ratio of the Emissions(kt) in European Union in 1999 to that in 2000?
Offer a terse response. 1. What is the ratio of the Emissions(kt) of Georgia in 1999 to that in 2000?
Keep it short and to the point. 0.96. What is the ratio of the Emissions(kt) of Ireland in 1999 to that in 2000?
Make the answer very short. 0.97. What is the ratio of the Emissions(kt) in Seychelles in 1999 to that in 2000?
Offer a very short reply. 0.91. What is the ratio of the Emissions(kt) in European Union in 1999 to that in 2001?
Give a very brief answer. 0.98. What is the ratio of the Emissions(kt) of Georgia in 1999 to that in 2001?
Your answer should be compact. 1.15. What is the ratio of the Emissions(kt) of Ireland in 1999 to that in 2001?
Keep it short and to the point. 0.91. What is the ratio of the Emissions(kt) of Seychelles in 1999 to that in 2001?
Your response must be concise. 0.8. What is the ratio of the Emissions(kt) of European Union in 1999 to that in 2002?
Your response must be concise. 0.98. What is the ratio of the Emissions(kt) in Georgia in 1999 to that in 2002?
Give a very brief answer. 1.28. What is the ratio of the Emissions(kt) in Ireland in 1999 to that in 2002?
Your answer should be very brief. 0.92. What is the ratio of the Emissions(kt) of Seychelles in 1999 to that in 2002?
Give a very brief answer. 0.94. What is the ratio of the Emissions(kt) in European Union in 1999 to that in 2003?
Provide a short and direct response. 0.96. What is the ratio of the Emissions(kt) in Georgia in 1999 to that in 2003?
Provide a succinct answer. 1.15. What is the ratio of the Emissions(kt) in Ireland in 1999 to that in 2003?
Give a very brief answer. 0.93. What is the ratio of the Emissions(kt) in European Union in 1999 to that in 2004?
Ensure brevity in your answer.  0.96. What is the ratio of the Emissions(kt) of Georgia in 1999 to that in 2004?
Keep it short and to the point. 1.01. What is the ratio of the Emissions(kt) in Ireland in 1999 to that in 2004?
Keep it short and to the point. 0.92. What is the ratio of the Emissions(kt) in Seychelles in 1999 to that in 2004?
Provide a short and direct response. 0.69. What is the ratio of the Emissions(kt) in European Union in 2000 to that in 2001?
Your answer should be compact. 0.98. What is the ratio of the Emissions(kt) of Georgia in 2000 to that in 2001?
Provide a short and direct response. 1.2. What is the ratio of the Emissions(kt) of Ireland in 2000 to that in 2001?
Your answer should be very brief. 0.94. What is the ratio of the Emissions(kt) of Seychelles in 2000 to that in 2001?
Offer a very short reply. 0.88. What is the ratio of the Emissions(kt) in Georgia in 2000 to that in 2002?
Provide a succinct answer. 1.34. What is the ratio of the Emissions(kt) in Ireland in 2000 to that in 2002?
Give a very brief answer. 0.95. What is the ratio of the Emissions(kt) in Seychelles in 2000 to that in 2002?
Your response must be concise. 1.03. What is the ratio of the Emissions(kt) in European Union in 2000 to that in 2003?
Give a very brief answer. 0.97. What is the ratio of the Emissions(kt) in Georgia in 2000 to that in 2003?
Your answer should be compact. 1.2. What is the ratio of the Emissions(kt) of Ireland in 2000 to that in 2003?
Offer a terse response. 0.95. What is the ratio of the Emissions(kt) of Seychelles in 2000 to that in 2003?
Offer a terse response. 1.01. What is the ratio of the Emissions(kt) in European Union in 2000 to that in 2004?
Your answer should be compact. 0.96. What is the ratio of the Emissions(kt) in Georgia in 2000 to that in 2004?
Offer a terse response. 1.05. What is the ratio of the Emissions(kt) in Ireland in 2000 to that in 2004?
Offer a very short reply. 0.94. What is the ratio of the Emissions(kt) in Seychelles in 2000 to that in 2004?
Ensure brevity in your answer.  0.76. What is the ratio of the Emissions(kt) in Georgia in 2001 to that in 2002?
Make the answer very short. 1.11. What is the ratio of the Emissions(kt) of Ireland in 2001 to that in 2002?
Your answer should be compact. 1.01. What is the ratio of the Emissions(kt) in Seychelles in 2001 to that in 2002?
Make the answer very short. 1.18. What is the ratio of the Emissions(kt) of European Union in 2001 to that in 2003?
Make the answer very short. 0.99. What is the ratio of the Emissions(kt) in Georgia in 2001 to that in 2003?
Ensure brevity in your answer.  1. What is the ratio of the Emissions(kt) in Ireland in 2001 to that in 2003?
Offer a terse response. 1.02. What is the ratio of the Emissions(kt) of Seychelles in 2001 to that in 2003?
Make the answer very short. 1.15. What is the ratio of the Emissions(kt) in European Union in 2001 to that in 2004?
Give a very brief answer. 0.99. What is the ratio of the Emissions(kt) in Georgia in 2001 to that in 2004?
Your answer should be compact. 0.87. What is the ratio of the Emissions(kt) in Seychelles in 2001 to that in 2004?
Your response must be concise. 0.86. What is the ratio of the Emissions(kt) of Georgia in 2002 to that in 2003?
Provide a short and direct response. 0.9. What is the ratio of the Emissions(kt) of Ireland in 2002 to that in 2003?
Your answer should be very brief. 1.01. What is the ratio of the Emissions(kt) in Seychelles in 2002 to that in 2003?
Offer a terse response. 0.98. What is the ratio of the Emissions(kt) in European Union in 2002 to that in 2004?
Your response must be concise. 0.98. What is the ratio of the Emissions(kt) in Georgia in 2002 to that in 2004?
Provide a succinct answer. 0.78. What is the ratio of the Emissions(kt) in Seychelles in 2002 to that in 2004?
Offer a very short reply. 0.73. What is the ratio of the Emissions(kt) in Georgia in 2003 to that in 2004?
Your answer should be very brief. 0.87. What is the ratio of the Emissions(kt) of Ireland in 2003 to that in 2004?
Keep it short and to the point. 0.99. What is the ratio of the Emissions(kt) of Seychelles in 2003 to that in 2004?
Ensure brevity in your answer.  0.75. What is the difference between the highest and the second highest Emissions(kt) of European Union?
Your response must be concise. 1.03e+04. What is the difference between the highest and the second highest Emissions(kt) of Georgia?
Give a very brief answer. 425.37. What is the difference between the highest and the second highest Emissions(kt) in Ireland?
Offer a very short reply. 205.35. What is the difference between the highest and the second highest Emissions(kt) in Seychelles?
Provide a short and direct response. 102.68. What is the difference between the highest and the lowest Emissions(kt) in European Union?
Offer a very short reply. 1.59e+05. What is the difference between the highest and the lowest Emissions(kt) in Georgia?
Offer a very short reply. 1573.14. What is the difference between the highest and the lowest Emissions(kt) of Ireland?
Your response must be concise. 5460.16. What is the difference between the highest and the lowest Emissions(kt) of Seychelles?
Your answer should be very brief. 304.36. 